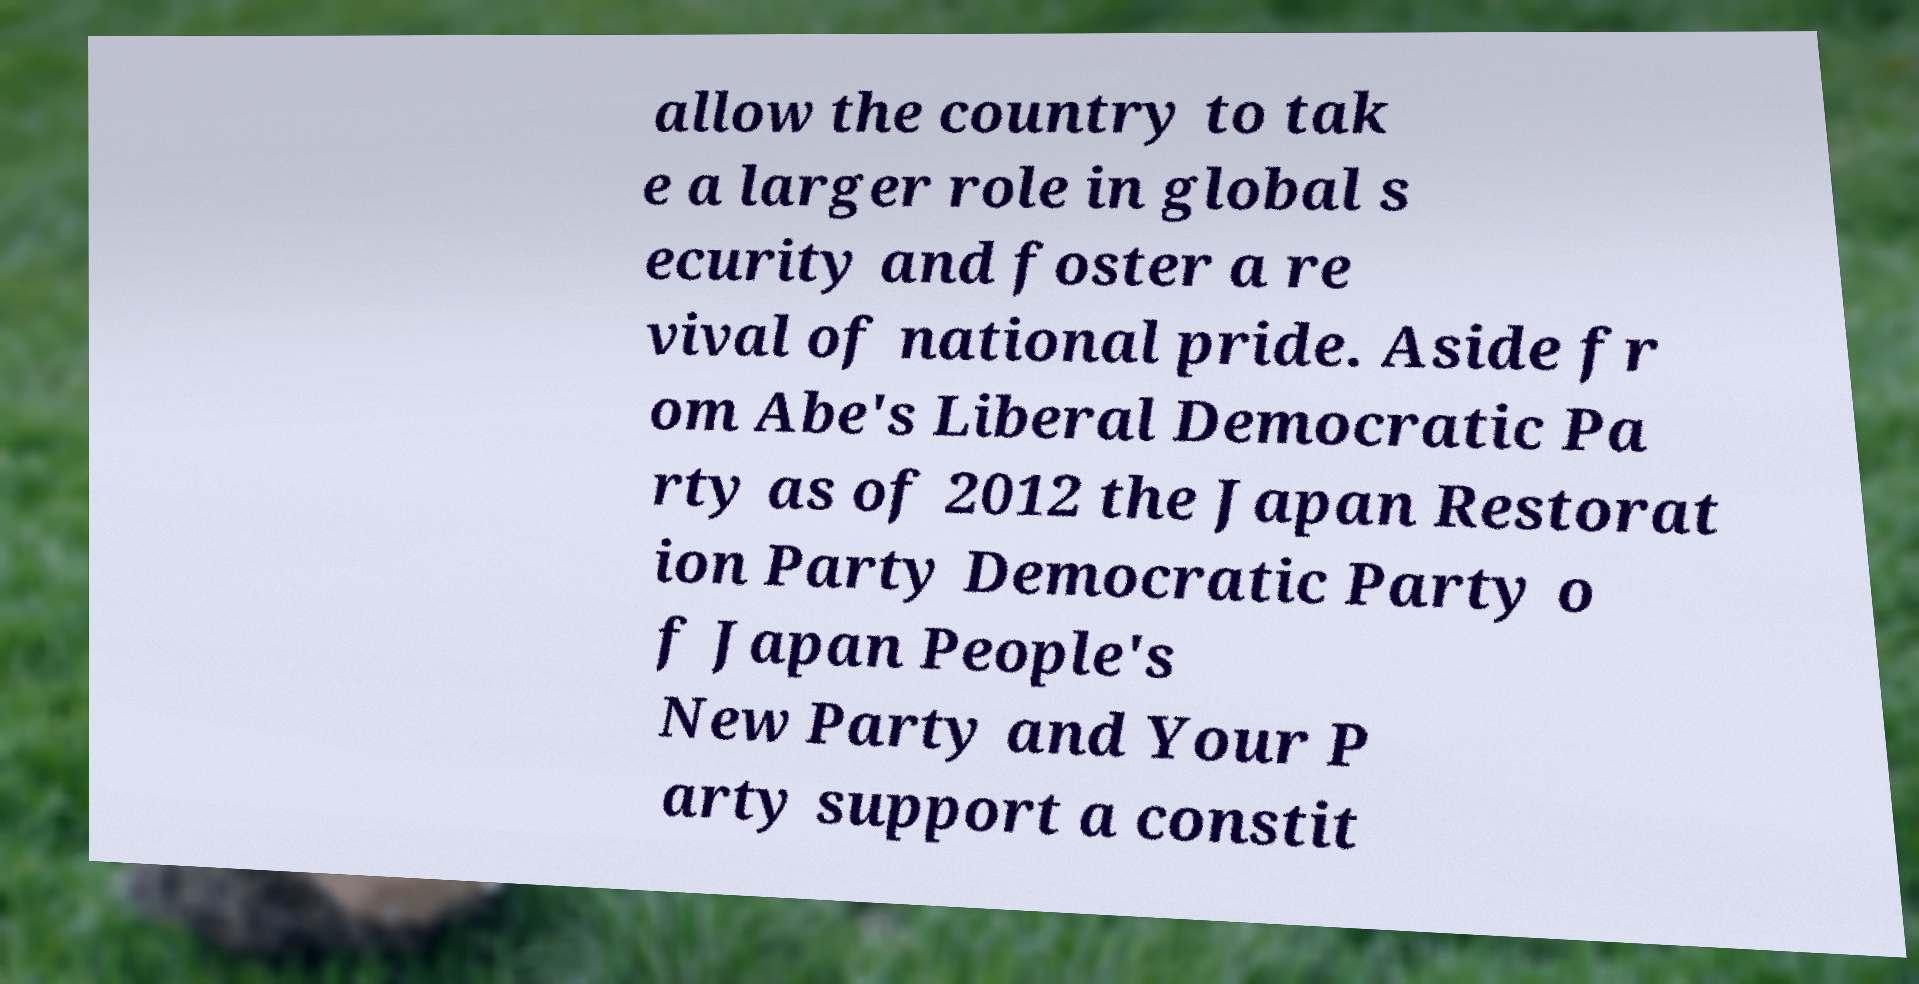Can you read and provide the text displayed in the image?This photo seems to have some interesting text. Can you extract and type it out for me? allow the country to tak e a larger role in global s ecurity and foster a re vival of national pride. Aside fr om Abe's Liberal Democratic Pa rty as of 2012 the Japan Restorat ion Party Democratic Party o f Japan People's New Party and Your P arty support a constit 